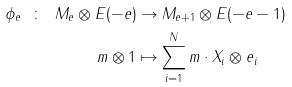Convert formula to latex. <formula><loc_0><loc_0><loc_500><loc_500>\phi _ { e } \ \colon \ M _ { e } \otimes E ( - e ) & \to M _ { e + 1 } \otimes E ( - e - 1 ) \\ m \otimes 1 & \mapsto \sum _ { i = 1 } ^ { N } m \cdot X _ { i } \otimes e _ { i }</formula> 